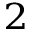<formula> <loc_0><loc_0><loc_500><loc_500>^ { 2 }</formula> 